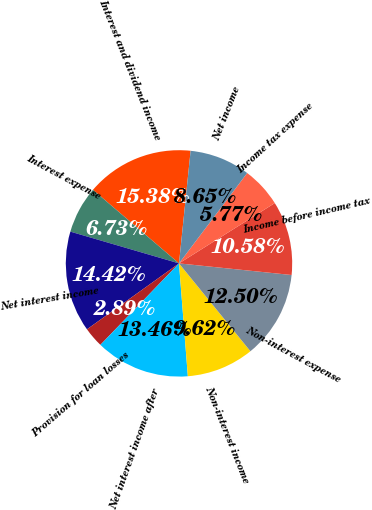Convert chart. <chart><loc_0><loc_0><loc_500><loc_500><pie_chart><fcel>Interest and dividend income<fcel>Interest expense<fcel>Net interest income<fcel>Provision for loan losses<fcel>Net interest income after<fcel>Non-interest income<fcel>Non-interest expense<fcel>Income before income tax<fcel>Income tax expense<fcel>Net income<nl><fcel>15.38%<fcel>6.73%<fcel>14.42%<fcel>2.89%<fcel>13.46%<fcel>9.62%<fcel>12.5%<fcel>10.58%<fcel>5.77%<fcel>8.65%<nl></chart> 